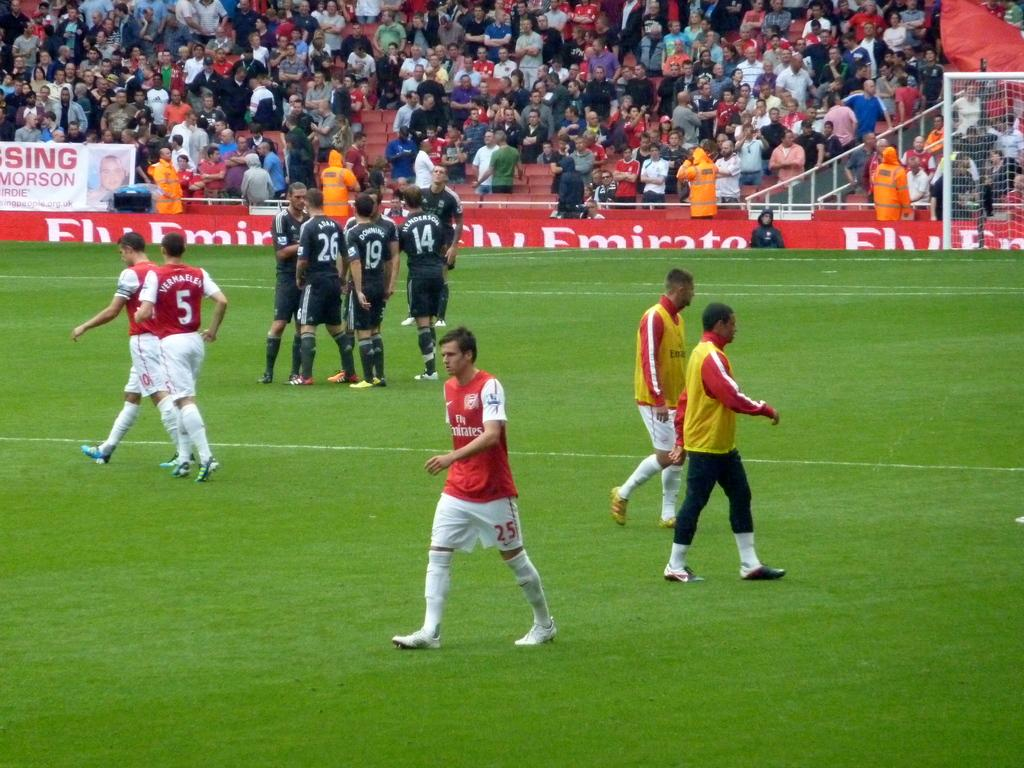<image>
Summarize the visual content of the image. Soccer players on a field with some wearing red shirts sponsored by Fly Emirates 